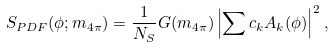<formula> <loc_0><loc_0><loc_500><loc_500>S _ { P D F } ( \phi ; m _ { 4 \pi } ) = \frac { 1 } { N _ { S } } G ( m _ { 4 \pi } ) \left | \sum c _ { k } A _ { k } ( \phi ) \right | ^ { 2 } ,</formula> 